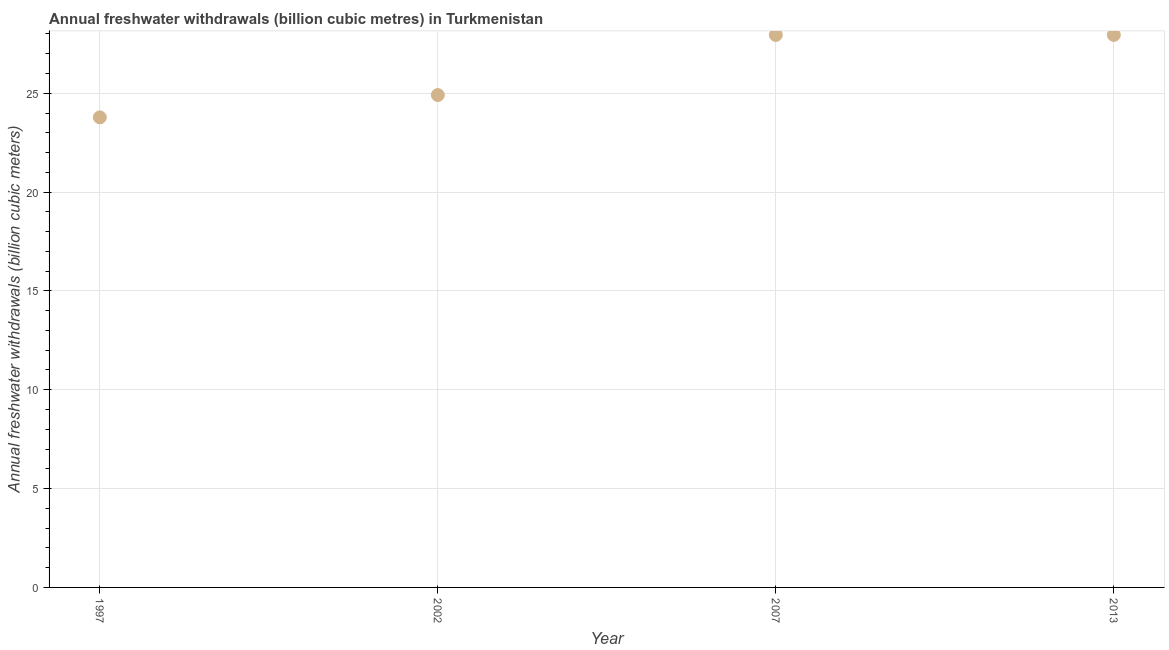What is the annual freshwater withdrawals in 2013?
Keep it short and to the point. 27.95. Across all years, what is the maximum annual freshwater withdrawals?
Your response must be concise. 27.95. Across all years, what is the minimum annual freshwater withdrawals?
Your answer should be very brief. 23.78. In which year was the annual freshwater withdrawals maximum?
Keep it short and to the point. 2007. What is the sum of the annual freshwater withdrawals?
Provide a succinct answer. 104.59. What is the difference between the annual freshwater withdrawals in 2007 and 2013?
Your answer should be very brief. 0. What is the average annual freshwater withdrawals per year?
Your answer should be very brief. 26.15. What is the median annual freshwater withdrawals?
Offer a terse response. 26.43. What is the ratio of the annual freshwater withdrawals in 1997 to that in 2013?
Provide a short and direct response. 0.85. Is the annual freshwater withdrawals in 2002 less than that in 2007?
Give a very brief answer. Yes. Is the difference between the annual freshwater withdrawals in 2002 and 2007 greater than the difference between any two years?
Make the answer very short. No. What is the difference between the highest and the second highest annual freshwater withdrawals?
Ensure brevity in your answer.  0. What is the difference between the highest and the lowest annual freshwater withdrawals?
Your answer should be compact. 4.17. In how many years, is the annual freshwater withdrawals greater than the average annual freshwater withdrawals taken over all years?
Offer a terse response. 2. Does the annual freshwater withdrawals monotonically increase over the years?
Your response must be concise. No. How many dotlines are there?
Your response must be concise. 1. Are the values on the major ticks of Y-axis written in scientific E-notation?
Give a very brief answer. No. Does the graph contain any zero values?
Provide a succinct answer. No. Does the graph contain grids?
Give a very brief answer. Yes. What is the title of the graph?
Ensure brevity in your answer.  Annual freshwater withdrawals (billion cubic metres) in Turkmenistan. What is the label or title of the X-axis?
Ensure brevity in your answer.  Year. What is the label or title of the Y-axis?
Your answer should be very brief. Annual freshwater withdrawals (billion cubic meters). What is the Annual freshwater withdrawals (billion cubic meters) in 1997?
Your response must be concise. 23.78. What is the Annual freshwater withdrawals (billion cubic meters) in 2002?
Your answer should be compact. 24.91. What is the Annual freshwater withdrawals (billion cubic meters) in 2007?
Your answer should be very brief. 27.95. What is the Annual freshwater withdrawals (billion cubic meters) in 2013?
Provide a short and direct response. 27.95. What is the difference between the Annual freshwater withdrawals (billion cubic meters) in 1997 and 2002?
Provide a short and direct response. -1.13. What is the difference between the Annual freshwater withdrawals (billion cubic meters) in 1997 and 2007?
Ensure brevity in your answer.  -4.17. What is the difference between the Annual freshwater withdrawals (billion cubic meters) in 1997 and 2013?
Your response must be concise. -4.17. What is the difference between the Annual freshwater withdrawals (billion cubic meters) in 2002 and 2007?
Keep it short and to the point. -3.04. What is the difference between the Annual freshwater withdrawals (billion cubic meters) in 2002 and 2013?
Give a very brief answer. -3.04. What is the ratio of the Annual freshwater withdrawals (billion cubic meters) in 1997 to that in 2002?
Give a very brief answer. 0.95. What is the ratio of the Annual freshwater withdrawals (billion cubic meters) in 1997 to that in 2007?
Your answer should be very brief. 0.85. What is the ratio of the Annual freshwater withdrawals (billion cubic meters) in 1997 to that in 2013?
Offer a very short reply. 0.85. What is the ratio of the Annual freshwater withdrawals (billion cubic meters) in 2002 to that in 2007?
Your response must be concise. 0.89. What is the ratio of the Annual freshwater withdrawals (billion cubic meters) in 2002 to that in 2013?
Offer a very short reply. 0.89. What is the ratio of the Annual freshwater withdrawals (billion cubic meters) in 2007 to that in 2013?
Ensure brevity in your answer.  1. 